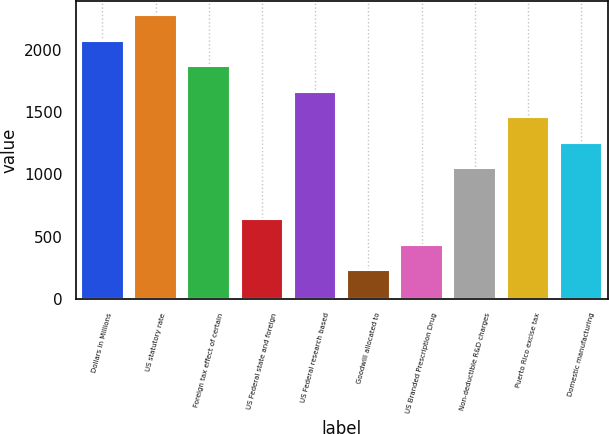<chart> <loc_0><loc_0><loc_500><loc_500><bar_chart><fcel>Dollars in Millions<fcel>US statutory rate<fcel>Foreign tax effect of certain<fcel>US Federal state and foreign<fcel>US Federal research based<fcel>Goodwill allocated to<fcel>US Branded Prescription Drug<fcel>Non-deductible R&D charges<fcel>Puerto Rico excise tax<fcel>Domestic manufacturing<nl><fcel>2070<fcel>2274.7<fcel>1865.3<fcel>637.1<fcel>1660.6<fcel>227.7<fcel>432.4<fcel>1046.5<fcel>1455.9<fcel>1251.2<nl></chart> 